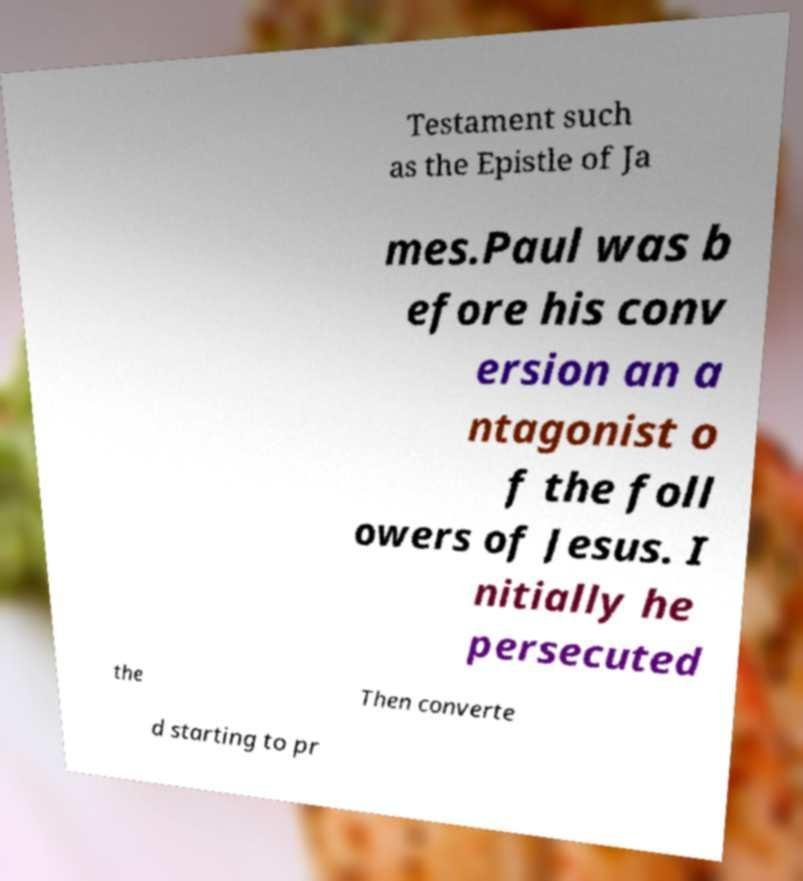Please read and relay the text visible in this image. What does it say? Testament such as the Epistle of Ja mes.Paul was b efore his conv ersion an a ntagonist o f the foll owers of Jesus. I nitially he persecuted the Then converte d starting to pr 